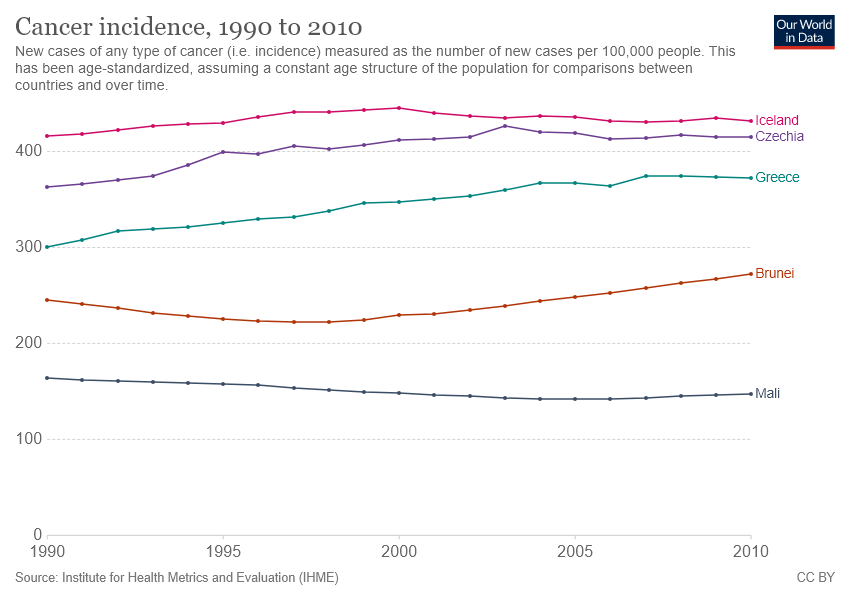Indicate a few pertinent items in this graphic. There are 5 countries featured in the chart. Iceland and the Czech Republic have the narrowest gap between them. 